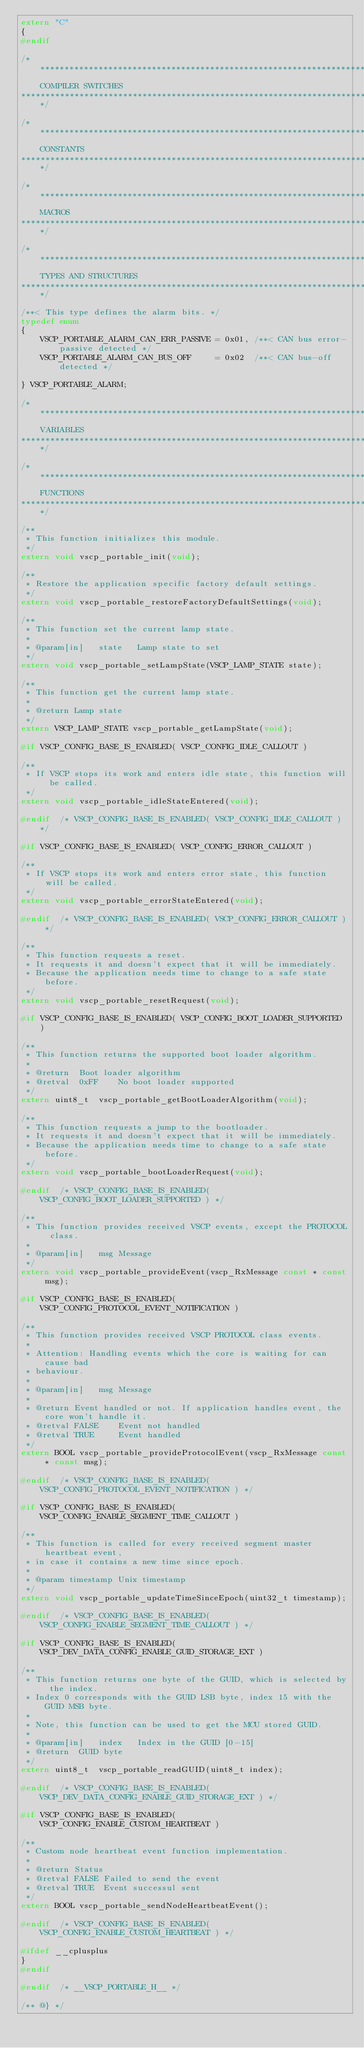Convert code to text. <code><loc_0><loc_0><loc_500><loc_500><_C_>extern "C"
{
#endif

/*******************************************************************************
    COMPILER SWITCHES
*******************************************************************************/

/*******************************************************************************
    CONSTANTS
*******************************************************************************/

/*******************************************************************************
    MACROS
*******************************************************************************/

/*******************************************************************************
    TYPES AND STRUCTURES
*******************************************************************************/

/**< This type defines the alarm bits. */
typedef enum
{
    VSCP_PORTABLE_ALARM_CAN_ERR_PASSIVE = 0x01, /**< CAN bus error-passive detected */
    VSCP_PORTABLE_ALARM_CAN_BUS_OFF     = 0x02  /**< CAN bus-off detected */

} VSCP_PORTABLE_ALARM;

/*******************************************************************************
    VARIABLES
*******************************************************************************/

/*******************************************************************************
    FUNCTIONS
*******************************************************************************/

/**
 * This function initializes this module.
 */
extern void vscp_portable_init(void);

/**
 * Restore the application specific factory default settings.
 */
extern void vscp_portable_restoreFactoryDefaultSettings(void);

/**
 * This function set the current lamp state.
 *
 * @param[in]   state   Lamp state to set
 */
extern void vscp_portable_setLampState(VSCP_LAMP_STATE state);

/**
 * This function get the current lamp state.
 *
 * @return Lamp state
 */
extern VSCP_LAMP_STATE vscp_portable_getLampState(void);

#if VSCP_CONFIG_BASE_IS_ENABLED( VSCP_CONFIG_IDLE_CALLOUT )

/**
 * If VSCP stops its work and enters idle state, this function will be called.
 */
extern void vscp_portable_idleStateEntered(void);

#endif  /* VSCP_CONFIG_BASE_IS_ENABLED( VSCP_CONFIG_IDLE_CALLOUT ) */

#if VSCP_CONFIG_BASE_IS_ENABLED( VSCP_CONFIG_ERROR_CALLOUT )

/**
 * If VSCP stops its work and enters error state, this function will be called.
 */
extern void vscp_portable_errorStateEntered(void);

#endif  /* VSCP_CONFIG_BASE_IS_ENABLED( VSCP_CONFIG_ERROR_CALLOUT ) */

/**
 * This function requests a reset.
 * It requests it and doesn't expect that it will be immediately.
 * Because the application needs time to change to a safe state before.
 */
extern void vscp_portable_resetRequest(void);

#if VSCP_CONFIG_BASE_IS_ENABLED( VSCP_CONFIG_BOOT_LOADER_SUPPORTED )

/**
 * This function returns the supported boot loader algorithm.
 *
 * @return  Boot loader algorithm
 * @retval  0xFF    No boot loader supported
 */
extern uint8_t  vscp_portable_getBootLoaderAlgorithm(void);

/**
 * This function requests a jump to the bootloader.
 * It requests it and doesn't expect that it will be immediately.
 * Because the application needs time to change to a safe state before.
 */
extern void vscp_portable_bootLoaderRequest(void);

#endif  /* VSCP_CONFIG_BASE_IS_ENABLED( VSCP_CONFIG_BOOT_LOADER_SUPPORTED ) */

/**
 * This function provides received VSCP events, except the PROTOCOL class.
 *
 * @param[in]   msg Message
 */
extern void vscp_portable_provideEvent(vscp_RxMessage const * const msg);

#if VSCP_CONFIG_BASE_IS_ENABLED( VSCP_CONFIG_PROTOCOL_EVENT_NOTIFICATION )

/**
 * This function provides received VSCP PROTOCOL class events.
 *
 * Attention: Handling events which the core is waiting for can cause bad
 * behaviour.
 * 
 * @param[in]   msg Message
 * 
 * @return Event handled or not. If application handles event, the core won't handle it.
 * @retval FALSE    Event not handled
 * @retval TRUE     Event handled
 */
extern BOOL vscp_portable_provideProtocolEvent(vscp_RxMessage const * const msg);

#endif  /* VSCP_CONFIG_BASE_IS_ENABLED( VSCP_CONFIG_PROTOCOL_EVENT_NOTIFICATION ) */

#if VSCP_CONFIG_BASE_IS_ENABLED( VSCP_CONFIG_ENABLE_SEGMENT_TIME_CALLOUT )

/**
 * This function is called for every received segment master heartbeat event,
 * in case it contains a new time since epoch.
 * 
 * @param timestamp Unix timestamp
 */
extern void vscp_portable_updateTimeSinceEpoch(uint32_t timestamp);

#endif  /* VSCP_CONFIG_BASE_IS_ENABLED( VSCP_CONFIG_ENABLE_SEGMENT_TIME_CALLOUT ) */

#if VSCP_CONFIG_BASE_IS_ENABLED( VSCP_DEV_DATA_CONFIG_ENABLE_GUID_STORAGE_EXT )

/**
 * This function returns one byte of the GUID, which is selected by the index.
 * Index 0 corresponds with the GUID LSB byte, index 15 with the GUID MSB byte.
 * 
 * Note, this function can be used to get the MCU stored GUID.
 *
 * @param[in]   index   Index in the GUID [0-15]
 * @return  GUID byte
 */
extern uint8_t  vscp_portable_readGUID(uint8_t index);

#endif  /* VSCP_CONFIG_BASE_IS_ENABLED( VSCP_DEV_DATA_CONFIG_ENABLE_GUID_STORAGE_EXT ) */

#if VSCP_CONFIG_BASE_IS_ENABLED( VSCP_CONFIG_ENABLE_CUSTOM_HEARTBEAT )

/**
 * Custom node heartbeat event function implementation.
 *
 * @return Status
 * @retval FALSE Failed to send the event
 * @retval TRUE  Event successul sent
 */
extern BOOL vscp_portable_sendNodeHeartbeatEvent();

#endif  /* VSCP_CONFIG_BASE_IS_ENABLED( VSCP_CONFIG_ENABLE_CUSTOM_HEARTBEAT ) */

#ifdef __cplusplus
}
#endif

#endif  /* __VSCP_PORTABLE_H__ */

/** @} */
</code> 